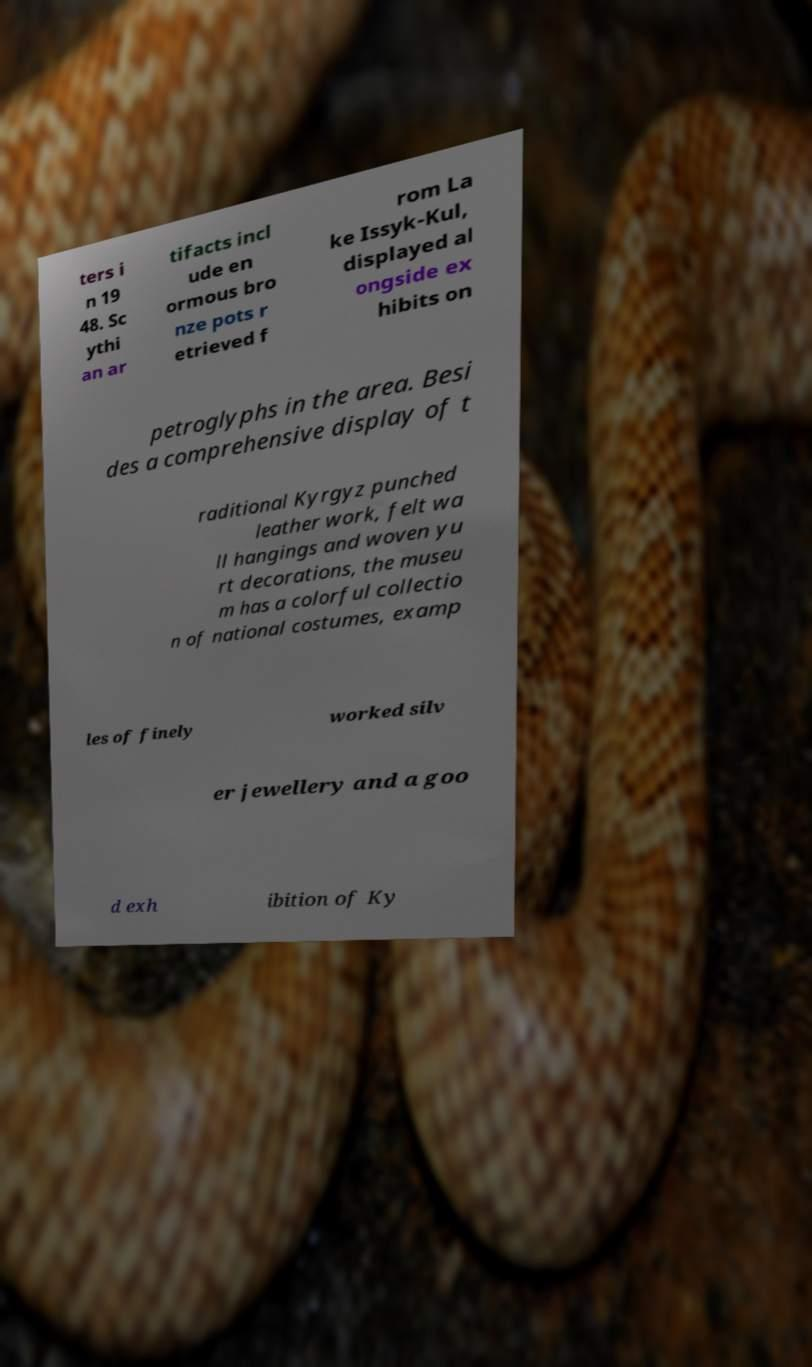What messages or text are displayed in this image? I need them in a readable, typed format. ters i n 19 48. Sc ythi an ar tifacts incl ude en ormous bro nze pots r etrieved f rom La ke Issyk-Kul, displayed al ongside ex hibits on petroglyphs in the area. Besi des a comprehensive display of t raditional Kyrgyz punched leather work, felt wa ll hangings and woven yu rt decorations, the museu m has a colorful collectio n of national costumes, examp les of finely worked silv er jewellery and a goo d exh ibition of Ky 